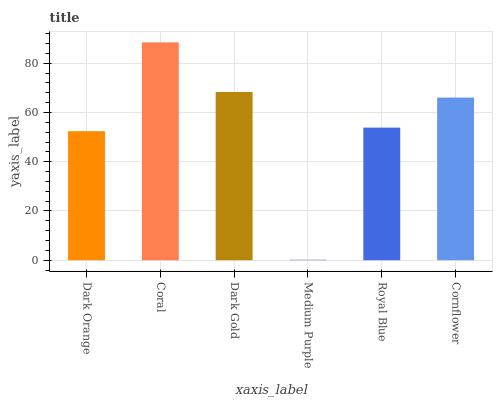Is Medium Purple the minimum?
Answer yes or no. Yes. Is Coral the maximum?
Answer yes or no. Yes. Is Dark Gold the minimum?
Answer yes or no. No. Is Dark Gold the maximum?
Answer yes or no. No. Is Coral greater than Dark Gold?
Answer yes or no. Yes. Is Dark Gold less than Coral?
Answer yes or no. Yes. Is Dark Gold greater than Coral?
Answer yes or no. No. Is Coral less than Dark Gold?
Answer yes or no. No. Is Cornflower the high median?
Answer yes or no. Yes. Is Royal Blue the low median?
Answer yes or no. Yes. Is Coral the high median?
Answer yes or no. No. Is Dark Gold the low median?
Answer yes or no. No. 